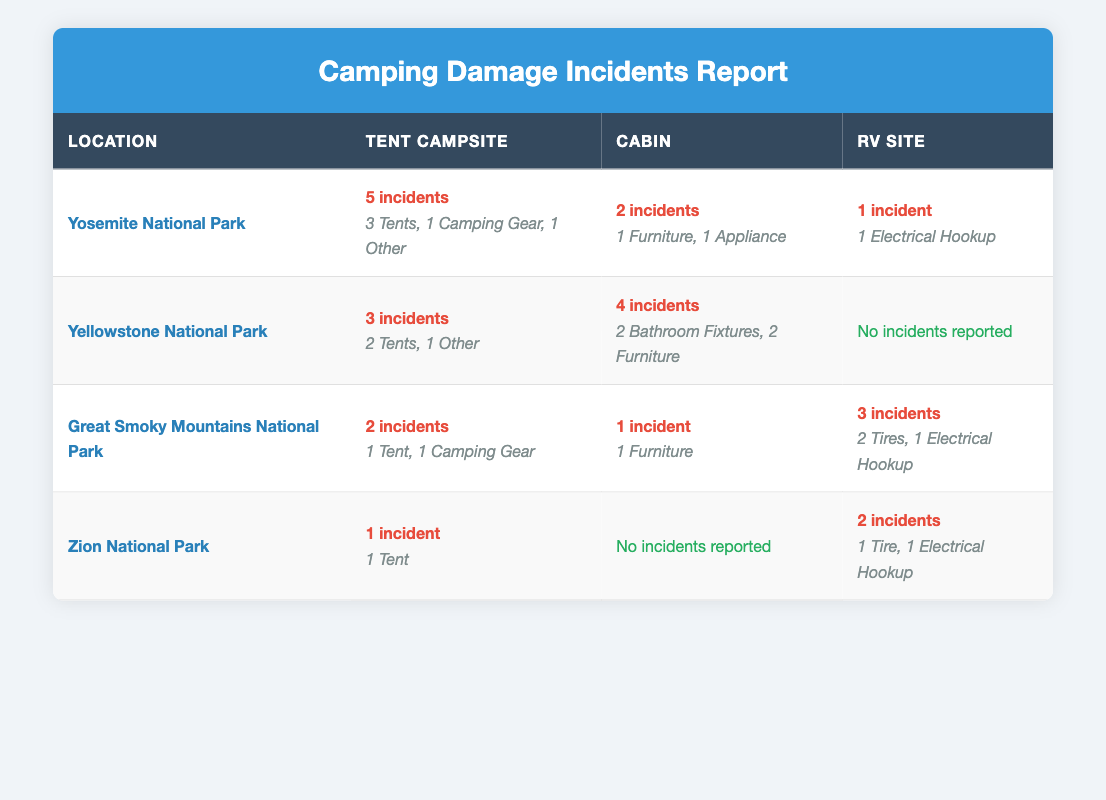What is the total number of incidents reported at Yosemite National Park? At Yosemite National Park, the table shows that there were a total of 5 incidents in the Tent Campsite, 2 incidents in the Cabin, and 1 incident in the RV Site. Adding these values together gives 5 + 2 + 1 = 8 incidents.
Answer: 8 Which camping location has the highest number of reported incidents? By comparing the total incidents across all locations, we can see that Yosemite National Park has 8 incidents, Yellowstone has 7 incidents, Great Smoky Mountains has 6 incidents, and Zion has 3 incidents. Therefore, Yosemite National Park has the highest number of reported incidents.
Answer: Yosemite National Park How many incidents were reported for RV Sites across all locations? The incidents reported for RV Sites include 1 incident in Yosemite, 0 incidents in Yellowstone, 3 incidents in Great Smoky Mountains, and 2 incidents in Zion. Adding these gives: 1 + 0 + 3 + 2 = 6 incidents reported for RV Sites.
Answer: 6 Did any cabins in Zion National Park report incidents? Referring to the table, it shows that incidents reported for cabins in Zion National Park are marked as "No incidents reported." This indicates that there were no incidents associated with cabins in that location.
Answer: No What is the average number of incidents for Tent Campsites across all locations? First, we need to find the total incidents for Tent Campsites: 5 in Yosemite, 3 in Yellowstone, 2 in Great Smoky Mountains, and 1 in Zion. Adding these gives us 5 + 3 + 2 + 1 = 11 incidents. There are 4 locations, so the average is 11/4 = 2.75 incidents.
Answer: 2.75 Which type of accommodation had the fewest reported incidents? By examining the incidents for each type of accommodation, we see 1 for RV Sites in Yosemite, 0 for RV Sites in Yellowstone, 2 for RV Sites in Great Smoky Mountains, and 2 for RV Sites in Zion, along with the incidents in other categories. Looking across all types, Cabins in Zion reported 0 incidents which is fewer than any other accommodation type.
Answer: Cabins in Zion National Park How many total incidents involve Tents across all locations? Summing the incidents involving Tents: Yosemite has 3, Yellowstone has 2, Great Smoky Mountains has 1, and Zion has 1. Adding these gives us 3 + 2 + 1 + 1 = 7 incidents involving Tents.
Answer: 7 Is there a location where no incidents were reported for RV Sites? The table shows that Yellowstone National Park has 0 incidents reported for RV Sites. Therefore, the answer is yes.
Answer: Yes What percentage of the total incidents reported at Yellowstone National Park were for cabins? Yellowstone has a total of 7 incidents (3 for Tent Campsites and 4 for Cabins). The number of incidents for cabins is 4. To find the percentage: (4 incidents for cabins / 7 total incidents) * 100 = approximately 57.14%.
Answer: 57.14% 